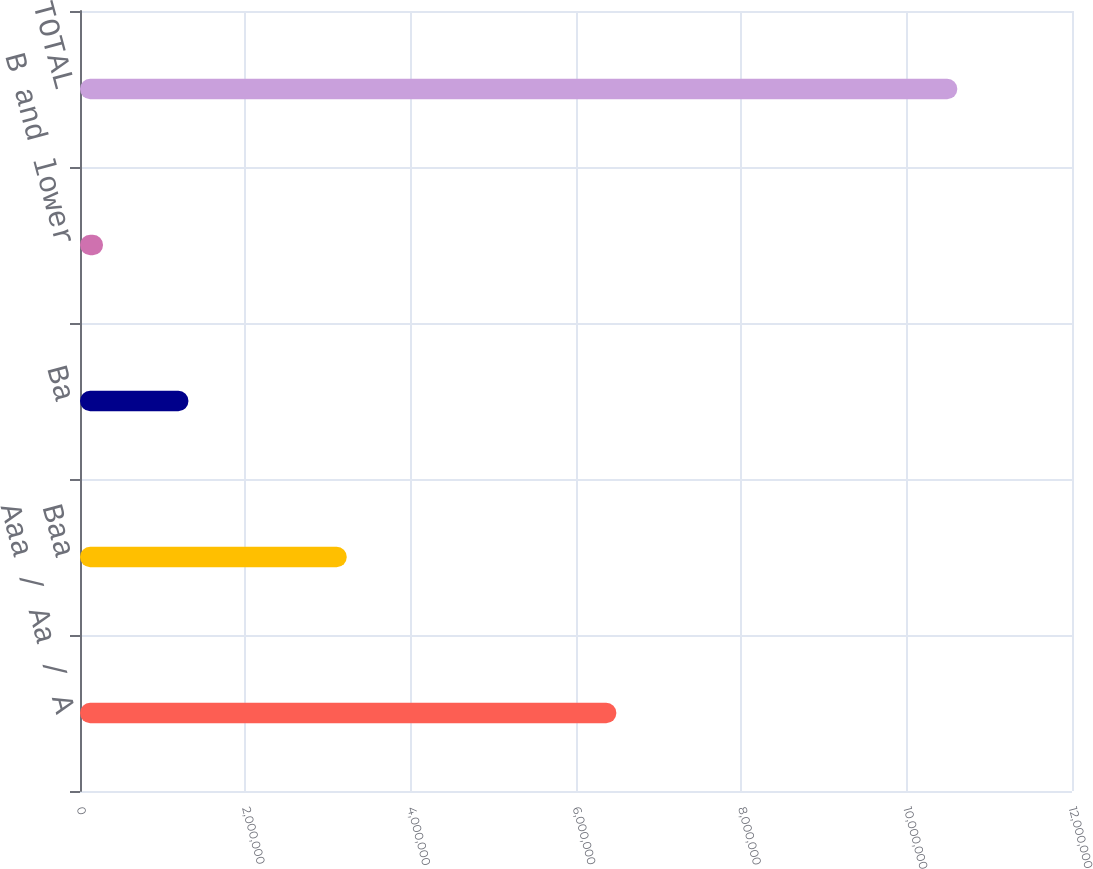Convert chart to OTSL. <chart><loc_0><loc_0><loc_500><loc_500><bar_chart><fcel>Aaa / Aa / A<fcel>Baa<fcel>Ba<fcel>B and lower<fcel>TOTAL<nl><fcel>6.48821e+06<fcel>3.22722e+06<fcel>1.31205e+06<fcel>278663<fcel>1.06126e+07<nl></chart> 